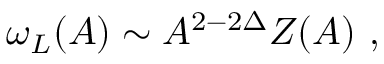<formula> <loc_0><loc_0><loc_500><loc_500>\omega _ { L } ( A ) \sim A ^ { 2 - 2 \Delta } Z ( A ) \ ,</formula> 